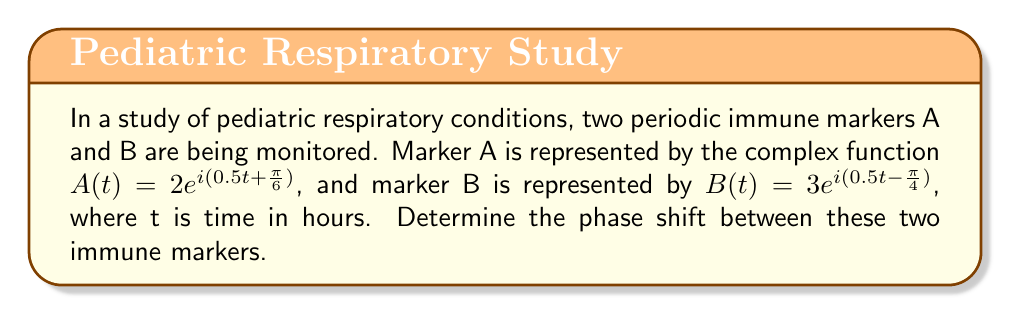What is the answer to this math problem? To find the phase shift between two periodic functions represented by complex exponentials, we need to compare their arguments. The general form of a complex exponential is $re^{i(\omega t + \phi)}$, where $\phi$ represents the phase.

For marker A: $A(t) = 2e^{i(0.5t + \frac{\pi}{6})}$
Phase of A: $\phi_A = \frac{\pi}{6}$

For marker B: $B(t) = 3e^{i(0.5t - \frac{\pi}{4})}$
Phase of B: $\phi_B = -\frac{\pi}{4}$

The phase shift is the difference between these phases:

$$\text{Phase shift} = \phi_A - \phi_B = \frac{\pi}{6} - (-\frac{\pi}{4}) = \frac{\pi}{6} + \frac{\pi}{4}$$

$$\text{Phase shift} = \frac{\pi}{6} + \frac{\pi}{4} = \frac{2\pi}{12} + \frac{3\pi}{12} = \frac{5\pi}{12}$$

To convert this to a more intuitive representation, we can express it in terms of a full cycle (2π):

$$\frac{5\pi}{12} = \frac{5}{24} \cdot 2\pi$$

This means the phase shift is $\frac{5}{24}$ of a full cycle, or equivalently, $\frac{5}{24} \cdot 360° = 75°$.
Answer: The phase shift between the two immune markers is $\frac{5\pi}{12}$ radians or 75°. 